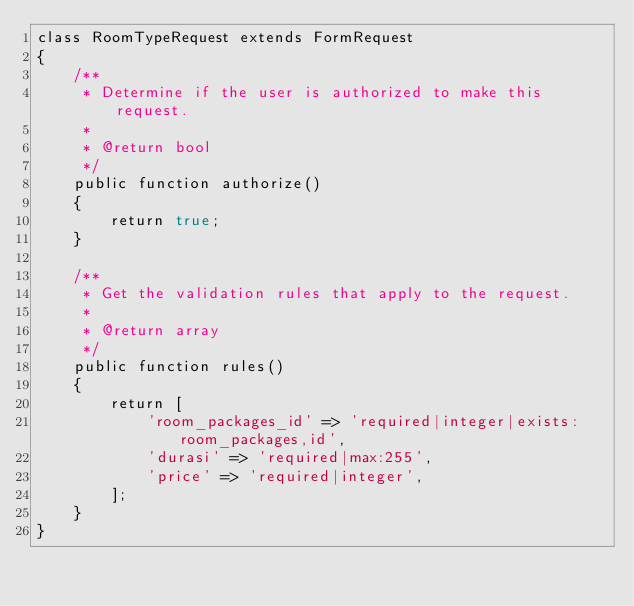<code> <loc_0><loc_0><loc_500><loc_500><_PHP_>class RoomTypeRequest extends FormRequest
{
    /**
     * Determine if the user is authorized to make this request.
     *
     * @return bool
     */
    public function authorize()
    {
        return true;
    }

    /**
     * Get the validation rules that apply to the request.
     *
     * @return array
     */
    public function rules()
    {
        return [
            'room_packages_id' => 'required|integer|exists:room_packages,id',
            'durasi' => 'required|max:255',
            'price' => 'required|integer',
        ];
    }
}
</code> 